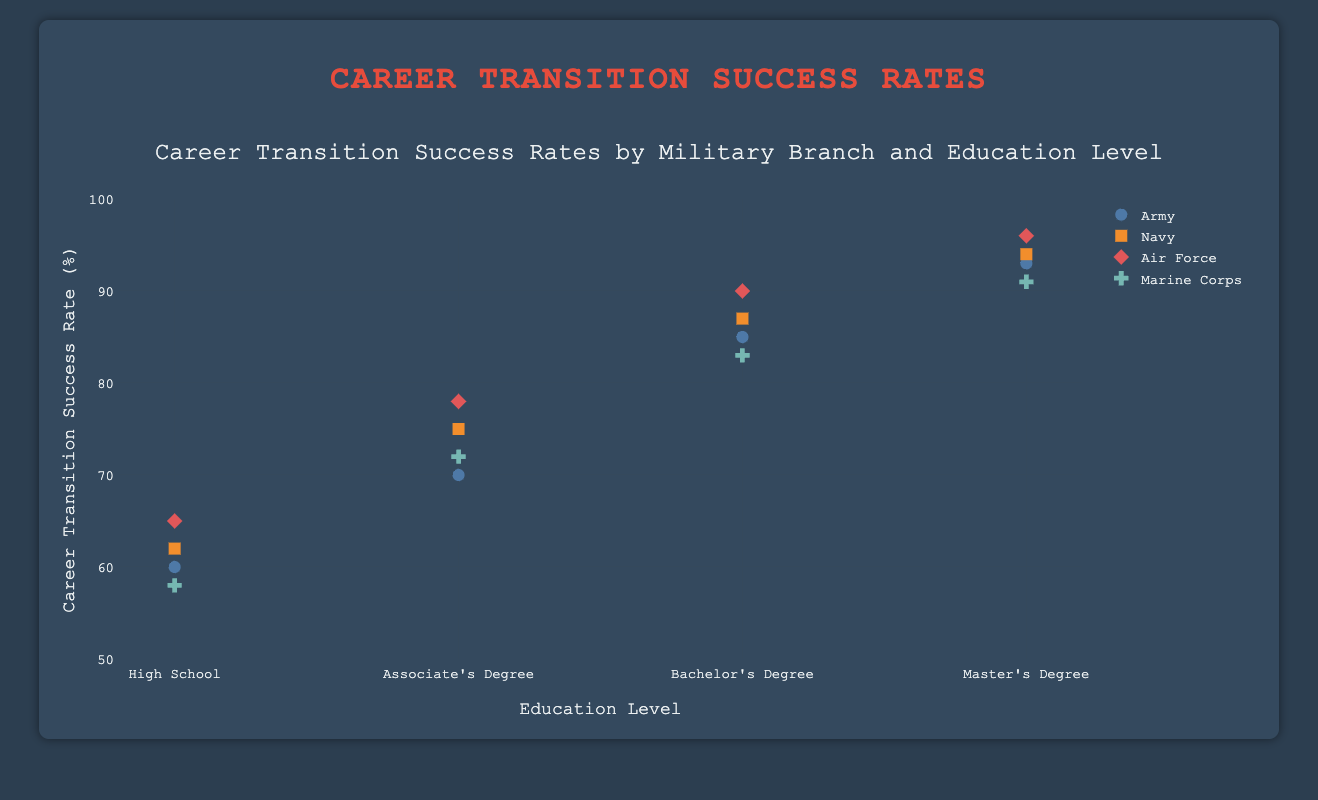What is the career transition success rate for the Marine Corps with a Bachelor's Degree? The data point for the Marine Corps with a Bachelor's Degree shows a career transition success rate (%) of 83.
Answer: 83 Which military branch has the highest career transition success rate at the Master's Degree level? By looking at the y-values for the Master's Degree level, the Air Force has the highest career transition success rate at 96%.
Answer: Air Force What is the difference in career transition success rate between a High School and a Master's Degree for the Army? The career transition success rate for the Army is 60% at the High School level and 93% at the Master's Degree level. The difference is 93% - 60% = 33%.
Answer: 33% Which education level shows the greatest increase in career transition success rate for the Navy from the previous level? The career transition rates for the Navy by education level are: High School (62%), Associate's Degree (75%), Bachelor's Degree (87%), and Master's Degree (94%). The increases are 75% - 62% = 13%, 87% - 75% = 12%, and 94% - 87% = 7%. The greatest increase is from High School to Associate's Degree (13%).
Answer: High School to Associate's Degree How many data points are there in total on the plot? Since there are 4 education levels and 4 military branches, we have 4 * 4 = 16 data points in total.
Answer: 16 Which military branch consistently has the highest career transition success rates across all education levels? By examining each education level, the Air Force has the highest career transition success rate for High School (65%), Associate's Degree (78%), Bachelor's Degree (90%), and Master's Degree (96%).
Answer: Air Force At which education level does the Marine Corps experience their lowest career transition success rate? For the Marine Corps, the career transition success rates are 58% (High School), 72% (Associate's Degree), 83% (Bachelor's Degree), and 91% (Master's Degree). The lowest rate is at the High School level (58%).
Answer: High School What is the average career transition success rate for the military branches at the Bachelor's Degree level? The rates are Army (85%), Navy (87%), Air Force (90%), and Marine Corps (83%). The average is (85 + 87 + 90 + 83) / 4 = 86.25%.
Answer: 86.25% Which military branch shows the smallest difference in career transition success rate between the High School and Master's Degree levels? The differences are: Army (93% - 60% = 33%), Navy (94% - 62% = 32%), Air Force (96% - 65% = 31%), and Marine Corps (91% - 58% = 33%). The smallest difference is for the Air Force (31%).
Answer: Air Force 